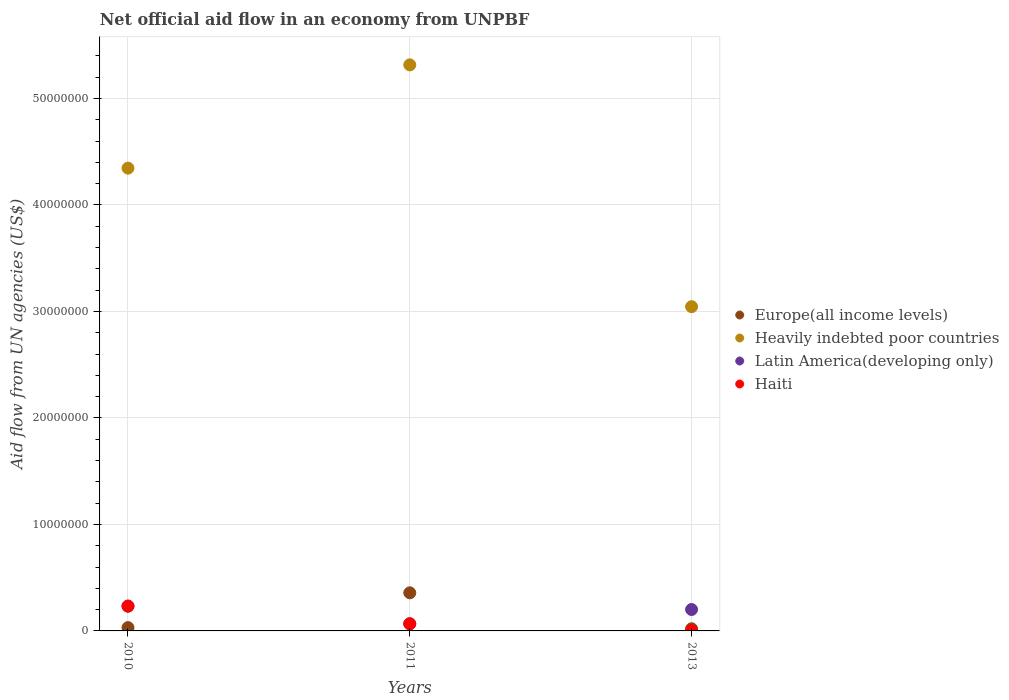How many different coloured dotlines are there?
Provide a succinct answer. 4. Is the number of dotlines equal to the number of legend labels?
Provide a short and direct response. Yes. What is the net official aid flow in Europe(all income levels) in 2013?
Provide a succinct answer. 2.00e+05. Across all years, what is the maximum net official aid flow in Europe(all income levels)?
Give a very brief answer. 3.58e+06. Across all years, what is the minimum net official aid flow in Europe(all income levels)?
Make the answer very short. 2.00e+05. What is the total net official aid flow in Heavily indebted poor countries in the graph?
Offer a terse response. 1.27e+08. What is the difference between the net official aid flow in Heavily indebted poor countries in 2010 and that in 2011?
Your answer should be very brief. -9.70e+06. What is the difference between the net official aid flow in Heavily indebted poor countries in 2013 and the net official aid flow in Europe(all income levels) in 2010?
Make the answer very short. 3.01e+07. What is the average net official aid flow in Haiti per year?
Ensure brevity in your answer.  1.01e+06. In the year 2011, what is the difference between the net official aid flow in Haiti and net official aid flow in Europe(all income levels)?
Your answer should be compact. -2.91e+06. What is the ratio of the net official aid flow in Latin America(developing only) in 2010 to that in 2013?
Offer a terse response. 1.16. Is the difference between the net official aid flow in Haiti in 2011 and 2013 greater than the difference between the net official aid flow in Europe(all income levels) in 2011 and 2013?
Offer a terse response. No. What is the difference between the highest and the second highest net official aid flow in Europe(all income levels)?
Your response must be concise. 3.27e+06. What is the difference between the highest and the lowest net official aid flow in Europe(all income levels)?
Your answer should be compact. 3.38e+06. In how many years, is the net official aid flow in Heavily indebted poor countries greater than the average net official aid flow in Heavily indebted poor countries taken over all years?
Your response must be concise. 2. Is the sum of the net official aid flow in Heavily indebted poor countries in 2010 and 2013 greater than the maximum net official aid flow in Latin America(developing only) across all years?
Your response must be concise. Yes. Is it the case that in every year, the sum of the net official aid flow in Latin America(developing only) and net official aid flow in Europe(all income levels)  is greater than the net official aid flow in Haiti?
Your response must be concise. Yes. Does the net official aid flow in Heavily indebted poor countries monotonically increase over the years?
Give a very brief answer. No. Is the net official aid flow in Latin America(developing only) strictly greater than the net official aid flow in Haiti over the years?
Your answer should be compact. No. Is the net official aid flow in Heavily indebted poor countries strictly less than the net official aid flow in Europe(all income levels) over the years?
Your answer should be very brief. No. How many dotlines are there?
Your response must be concise. 4. How many years are there in the graph?
Offer a very short reply. 3. What is the difference between two consecutive major ticks on the Y-axis?
Give a very brief answer. 1.00e+07. Does the graph contain any zero values?
Offer a very short reply. No. Does the graph contain grids?
Provide a succinct answer. Yes. Where does the legend appear in the graph?
Your answer should be very brief. Center right. How many legend labels are there?
Ensure brevity in your answer.  4. How are the legend labels stacked?
Offer a terse response. Vertical. What is the title of the graph?
Your answer should be compact. Net official aid flow in an economy from UNPBF. Does "Austria" appear as one of the legend labels in the graph?
Offer a terse response. No. What is the label or title of the X-axis?
Ensure brevity in your answer.  Years. What is the label or title of the Y-axis?
Make the answer very short. Aid flow from UN agencies (US$). What is the Aid flow from UN agencies (US$) of Heavily indebted poor countries in 2010?
Offer a terse response. 4.35e+07. What is the Aid flow from UN agencies (US$) in Latin America(developing only) in 2010?
Ensure brevity in your answer.  2.33e+06. What is the Aid flow from UN agencies (US$) in Haiti in 2010?
Provide a short and direct response. 2.33e+06. What is the Aid flow from UN agencies (US$) of Europe(all income levels) in 2011?
Keep it short and to the point. 3.58e+06. What is the Aid flow from UN agencies (US$) of Heavily indebted poor countries in 2011?
Ensure brevity in your answer.  5.32e+07. What is the Aid flow from UN agencies (US$) in Latin America(developing only) in 2011?
Give a very brief answer. 6.70e+05. What is the Aid flow from UN agencies (US$) in Haiti in 2011?
Offer a very short reply. 6.70e+05. What is the Aid flow from UN agencies (US$) in Europe(all income levels) in 2013?
Make the answer very short. 2.00e+05. What is the Aid flow from UN agencies (US$) of Heavily indebted poor countries in 2013?
Ensure brevity in your answer.  3.04e+07. What is the Aid flow from UN agencies (US$) of Latin America(developing only) in 2013?
Your response must be concise. 2.01e+06. Across all years, what is the maximum Aid flow from UN agencies (US$) in Europe(all income levels)?
Your answer should be compact. 3.58e+06. Across all years, what is the maximum Aid flow from UN agencies (US$) of Heavily indebted poor countries?
Your response must be concise. 5.32e+07. Across all years, what is the maximum Aid flow from UN agencies (US$) of Latin America(developing only)?
Ensure brevity in your answer.  2.33e+06. Across all years, what is the maximum Aid flow from UN agencies (US$) in Haiti?
Give a very brief answer. 2.33e+06. Across all years, what is the minimum Aid flow from UN agencies (US$) of Heavily indebted poor countries?
Offer a terse response. 3.04e+07. Across all years, what is the minimum Aid flow from UN agencies (US$) in Latin America(developing only)?
Your response must be concise. 6.70e+05. What is the total Aid flow from UN agencies (US$) in Europe(all income levels) in the graph?
Give a very brief answer. 4.09e+06. What is the total Aid flow from UN agencies (US$) in Heavily indebted poor countries in the graph?
Provide a succinct answer. 1.27e+08. What is the total Aid flow from UN agencies (US$) of Latin America(developing only) in the graph?
Your answer should be very brief. 5.01e+06. What is the total Aid flow from UN agencies (US$) of Haiti in the graph?
Ensure brevity in your answer.  3.02e+06. What is the difference between the Aid flow from UN agencies (US$) in Europe(all income levels) in 2010 and that in 2011?
Make the answer very short. -3.27e+06. What is the difference between the Aid flow from UN agencies (US$) of Heavily indebted poor countries in 2010 and that in 2011?
Offer a very short reply. -9.70e+06. What is the difference between the Aid flow from UN agencies (US$) in Latin America(developing only) in 2010 and that in 2011?
Ensure brevity in your answer.  1.66e+06. What is the difference between the Aid flow from UN agencies (US$) in Haiti in 2010 and that in 2011?
Your answer should be compact. 1.66e+06. What is the difference between the Aid flow from UN agencies (US$) in Europe(all income levels) in 2010 and that in 2013?
Offer a terse response. 1.10e+05. What is the difference between the Aid flow from UN agencies (US$) of Heavily indebted poor countries in 2010 and that in 2013?
Offer a very short reply. 1.30e+07. What is the difference between the Aid flow from UN agencies (US$) of Haiti in 2010 and that in 2013?
Make the answer very short. 2.31e+06. What is the difference between the Aid flow from UN agencies (US$) of Europe(all income levels) in 2011 and that in 2013?
Give a very brief answer. 3.38e+06. What is the difference between the Aid flow from UN agencies (US$) in Heavily indebted poor countries in 2011 and that in 2013?
Ensure brevity in your answer.  2.27e+07. What is the difference between the Aid flow from UN agencies (US$) in Latin America(developing only) in 2011 and that in 2013?
Give a very brief answer. -1.34e+06. What is the difference between the Aid flow from UN agencies (US$) of Haiti in 2011 and that in 2013?
Your response must be concise. 6.50e+05. What is the difference between the Aid flow from UN agencies (US$) in Europe(all income levels) in 2010 and the Aid flow from UN agencies (US$) in Heavily indebted poor countries in 2011?
Offer a terse response. -5.28e+07. What is the difference between the Aid flow from UN agencies (US$) in Europe(all income levels) in 2010 and the Aid flow from UN agencies (US$) in Latin America(developing only) in 2011?
Offer a terse response. -3.60e+05. What is the difference between the Aid flow from UN agencies (US$) in Europe(all income levels) in 2010 and the Aid flow from UN agencies (US$) in Haiti in 2011?
Make the answer very short. -3.60e+05. What is the difference between the Aid flow from UN agencies (US$) of Heavily indebted poor countries in 2010 and the Aid flow from UN agencies (US$) of Latin America(developing only) in 2011?
Provide a succinct answer. 4.28e+07. What is the difference between the Aid flow from UN agencies (US$) in Heavily indebted poor countries in 2010 and the Aid flow from UN agencies (US$) in Haiti in 2011?
Ensure brevity in your answer.  4.28e+07. What is the difference between the Aid flow from UN agencies (US$) of Latin America(developing only) in 2010 and the Aid flow from UN agencies (US$) of Haiti in 2011?
Your response must be concise. 1.66e+06. What is the difference between the Aid flow from UN agencies (US$) of Europe(all income levels) in 2010 and the Aid flow from UN agencies (US$) of Heavily indebted poor countries in 2013?
Provide a succinct answer. -3.01e+07. What is the difference between the Aid flow from UN agencies (US$) of Europe(all income levels) in 2010 and the Aid flow from UN agencies (US$) of Latin America(developing only) in 2013?
Offer a terse response. -1.70e+06. What is the difference between the Aid flow from UN agencies (US$) in Heavily indebted poor countries in 2010 and the Aid flow from UN agencies (US$) in Latin America(developing only) in 2013?
Provide a succinct answer. 4.14e+07. What is the difference between the Aid flow from UN agencies (US$) in Heavily indebted poor countries in 2010 and the Aid flow from UN agencies (US$) in Haiti in 2013?
Provide a short and direct response. 4.34e+07. What is the difference between the Aid flow from UN agencies (US$) in Latin America(developing only) in 2010 and the Aid flow from UN agencies (US$) in Haiti in 2013?
Offer a terse response. 2.31e+06. What is the difference between the Aid flow from UN agencies (US$) in Europe(all income levels) in 2011 and the Aid flow from UN agencies (US$) in Heavily indebted poor countries in 2013?
Give a very brief answer. -2.69e+07. What is the difference between the Aid flow from UN agencies (US$) in Europe(all income levels) in 2011 and the Aid flow from UN agencies (US$) in Latin America(developing only) in 2013?
Make the answer very short. 1.57e+06. What is the difference between the Aid flow from UN agencies (US$) of Europe(all income levels) in 2011 and the Aid flow from UN agencies (US$) of Haiti in 2013?
Ensure brevity in your answer.  3.56e+06. What is the difference between the Aid flow from UN agencies (US$) in Heavily indebted poor countries in 2011 and the Aid flow from UN agencies (US$) in Latin America(developing only) in 2013?
Ensure brevity in your answer.  5.12e+07. What is the difference between the Aid flow from UN agencies (US$) in Heavily indebted poor countries in 2011 and the Aid flow from UN agencies (US$) in Haiti in 2013?
Offer a terse response. 5.31e+07. What is the difference between the Aid flow from UN agencies (US$) in Latin America(developing only) in 2011 and the Aid flow from UN agencies (US$) in Haiti in 2013?
Make the answer very short. 6.50e+05. What is the average Aid flow from UN agencies (US$) of Europe(all income levels) per year?
Your answer should be very brief. 1.36e+06. What is the average Aid flow from UN agencies (US$) of Heavily indebted poor countries per year?
Your answer should be compact. 4.24e+07. What is the average Aid flow from UN agencies (US$) in Latin America(developing only) per year?
Your answer should be very brief. 1.67e+06. What is the average Aid flow from UN agencies (US$) in Haiti per year?
Your answer should be very brief. 1.01e+06. In the year 2010, what is the difference between the Aid flow from UN agencies (US$) in Europe(all income levels) and Aid flow from UN agencies (US$) in Heavily indebted poor countries?
Make the answer very short. -4.32e+07. In the year 2010, what is the difference between the Aid flow from UN agencies (US$) of Europe(all income levels) and Aid flow from UN agencies (US$) of Latin America(developing only)?
Give a very brief answer. -2.02e+06. In the year 2010, what is the difference between the Aid flow from UN agencies (US$) in Europe(all income levels) and Aid flow from UN agencies (US$) in Haiti?
Provide a succinct answer. -2.02e+06. In the year 2010, what is the difference between the Aid flow from UN agencies (US$) of Heavily indebted poor countries and Aid flow from UN agencies (US$) of Latin America(developing only)?
Your answer should be very brief. 4.11e+07. In the year 2010, what is the difference between the Aid flow from UN agencies (US$) in Heavily indebted poor countries and Aid flow from UN agencies (US$) in Haiti?
Ensure brevity in your answer.  4.11e+07. In the year 2011, what is the difference between the Aid flow from UN agencies (US$) of Europe(all income levels) and Aid flow from UN agencies (US$) of Heavily indebted poor countries?
Give a very brief answer. -4.96e+07. In the year 2011, what is the difference between the Aid flow from UN agencies (US$) in Europe(all income levels) and Aid flow from UN agencies (US$) in Latin America(developing only)?
Give a very brief answer. 2.91e+06. In the year 2011, what is the difference between the Aid flow from UN agencies (US$) of Europe(all income levels) and Aid flow from UN agencies (US$) of Haiti?
Offer a terse response. 2.91e+06. In the year 2011, what is the difference between the Aid flow from UN agencies (US$) in Heavily indebted poor countries and Aid flow from UN agencies (US$) in Latin America(developing only)?
Your answer should be compact. 5.25e+07. In the year 2011, what is the difference between the Aid flow from UN agencies (US$) in Heavily indebted poor countries and Aid flow from UN agencies (US$) in Haiti?
Give a very brief answer. 5.25e+07. In the year 2013, what is the difference between the Aid flow from UN agencies (US$) of Europe(all income levels) and Aid flow from UN agencies (US$) of Heavily indebted poor countries?
Give a very brief answer. -3.02e+07. In the year 2013, what is the difference between the Aid flow from UN agencies (US$) in Europe(all income levels) and Aid flow from UN agencies (US$) in Latin America(developing only)?
Offer a terse response. -1.81e+06. In the year 2013, what is the difference between the Aid flow from UN agencies (US$) of Europe(all income levels) and Aid flow from UN agencies (US$) of Haiti?
Provide a short and direct response. 1.80e+05. In the year 2013, what is the difference between the Aid flow from UN agencies (US$) in Heavily indebted poor countries and Aid flow from UN agencies (US$) in Latin America(developing only)?
Your answer should be very brief. 2.84e+07. In the year 2013, what is the difference between the Aid flow from UN agencies (US$) in Heavily indebted poor countries and Aid flow from UN agencies (US$) in Haiti?
Give a very brief answer. 3.04e+07. In the year 2013, what is the difference between the Aid flow from UN agencies (US$) in Latin America(developing only) and Aid flow from UN agencies (US$) in Haiti?
Give a very brief answer. 1.99e+06. What is the ratio of the Aid flow from UN agencies (US$) of Europe(all income levels) in 2010 to that in 2011?
Your answer should be very brief. 0.09. What is the ratio of the Aid flow from UN agencies (US$) in Heavily indebted poor countries in 2010 to that in 2011?
Offer a terse response. 0.82. What is the ratio of the Aid flow from UN agencies (US$) of Latin America(developing only) in 2010 to that in 2011?
Make the answer very short. 3.48. What is the ratio of the Aid flow from UN agencies (US$) in Haiti in 2010 to that in 2011?
Provide a succinct answer. 3.48. What is the ratio of the Aid flow from UN agencies (US$) in Europe(all income levels) in 2010 to that in 2013?
Keep it short and to the point. 1.55. What is the ratio of the Aid flow from UN agencies (US$) of Heavily indebted poor countries in 2010 to that in 2013?
Keep it short and to the point. 1.43. What is the ratio of the Aid flow from UN agencies (US$) in Latin America(developing only) in 2010 to that in 2013?
Keep it short and to the point. 1.16. What is the ratio of the Aid flow from UN agencies (US$) of Haiti in 2010 to that in 2013?
Give a very brief answer. 116.5. What is the ratio of the Aid flow from UN agencies (US$) in Europe(all income levels) in 2011 to that in 2013?
Give a very brief answer. 17.9. What is the ratio of the Aid flow from UN agencies (US$) of Heavily indebted poor countries in 2011 to that in 2013?
Offer a terse response. 1.75. What is the ratio of the Aid flow from UN agencies (US$) of Haiti in 2011 to that in 2013?
Give a very brief answer. 33.5. What is the difference between the highest and the second highest Aid flow from UN agencies (US$) in Europe(all income levels)?
Make the answer very short. 3.27e+06. What is the difference between the highest and the second highest Aid flow from UN agencies (US$) of Heavily indebted poor countries?
Your answer should be very brief. 9.70e+06. What is the difference between the highest and the second highest Aid flow from UN agencies (US$) in Haiti?
Your answer should be very brief. 1.66e+06. What is the difference between the highest and the lowest Aid flow from UN agencies (US$) of Europe(all income levels)?
Your answer should be very brief. 3.38e+06. What is the difference between the highest and the lowest Aid flow from UN agencies (US$) in Heavily indebted poor countries?
Make the answer very short. 2.27e+07. What is the difference between the highest and the lowest Aid flow from UN agencies (US$) of Latin America(developing only)?
Your answer should be compact. 1.66e+06. What is the difference between the highest and the lowest Aid flow from UN agencies (US$) of Haiti?
Provide a succinct answer. 2.31e+06. 